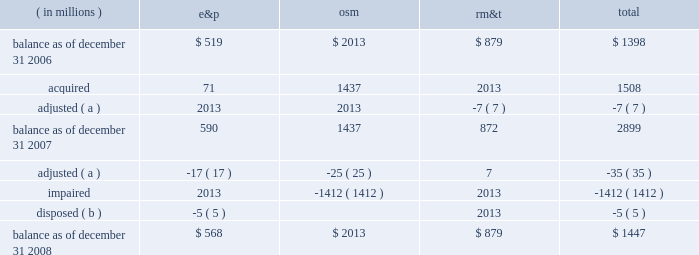Marathon oil corporation notes to consolidated financial statements the changes in the carrying amount of goodwill for the years ended december 31 , 2007 , and 2008 , were as follows : ( in millions ) e&p osm rm&t total .
( a ) adjustments related to prior period income tax and royalty adjustments .
( b ) goodwill was allocated to the norwegian outside-operated properties sold in 2008 .
17 .
Fair value measurements as defined in sfas no .
157 , fair value is the price that would be received to sell an asset or paid to transfer a liability in an orderly transaction between market participants at the measurement date .
Sfas no .
157 describes three approaches to measuring the fair value of assets and liabilities : the market approach , the income approach and the cost approach , each of which includes multiple valuation techniques .
The market approach uses prices and other relevant information generated by market transactions involving identical or comparable assets or liabilities .
The income approach uses valuation techniques to measure fair value by converting future amounts , such as cash flows or earnings , into a single present value amount using current market expectations about those future amounts .
The cost approach is based on the amount that would currently be required to replace the service capacity of an asset .
This is often referred to as current replacement cost .
The cost approach assumes that the fair value would not exceed what it would cost a market participant to acquire or construct a substitute asset of comparable utility , adjusted for obsolescence .
Sfas no .
157 does not prescribe which valuation technique should be used when measuring fair value and does not prioritize among the techniques .
Sfas no .
157 establishes a fair value hierarchy that prioritizes the inputs used in applying the various valuation techniques .
Inputs broadly refer to the assumptions that market participants use to make pricing decisions , including assumptions about risk .
Level 1 inputs are given the highest priority in the fair value hierarchy while level 3 inputs are given the lowest priority .
The three levels of the fair value hierarchy are as follows .
2022 level 1 2013 observable inputs that reflect unadjusted quoted prices for identical assets or liabilities in active markets as of the reporting date .
Active markets are those in which transactions for the asset or liability occur in sufficient frequency and volume to provide pricing information on an ongoing basis .
2022 level 2 2013 observable market-based inputs or unobservable inputs that are corroborated by market data .
These are inputs other than quoted prices in active markets included in level 1 , which are either directly or indirectly observable as of the reporting date .
2022 level 3 2013 unobservable inputs that are not corroborated by market data and may be used with internally developed methodologies that result in management 2019s best estimate of fair value .
We use a market or income approach for recurring fair value measurements and endeavor to use the best information available .
Accordingly , valuation techniques that maximize the use of observable inputs are favored .
Financial assets and liabilities are classified in their entirety based on the lowest priority level of input that is significant to the fair value measurement .
The assessment of the significance of a particular input to the fair value measurement requires judgment and may affect the placement of assets and liabilities within the levels of the fair value hierarchy. .
Excluding 2008 adjustments , what was the balance of the rm&t segment goodwill as of december 31 2008 , in millions? 
Computations: (879 - 7)
Answer: 872.0. Marathon oil corporation notes to consolidated financial statements the changes in the carrying amount of goodwill for the years ended december 31 , 2007 , and 2008 , were as follows : ( in millions ) e&p osm rm&t total .
( a ) adjustments related to prior period income tax and royalty adjustments .
( b ) goodwill was allocated to the norwegian outside-operated properties sold in 2008 .
17 .
Fair value measurements as defined in sfas no .
157 , fair value is the price that would be received to sell an asset or paid to transfer a liability in an orderly transaction between market participants at the measurement date .
Sfas no .
157 describes three approaches to measuring the fair value of assets and liabilities : the market approach , the income approach and the cost approach , each of which includes multiple valuation techniques .
The market approach uses prices and other relevant information generated by market transactions involving identical or comparable assets or liabilities .
The income approach uses valuation techniques to measure fair value by converting future amounts , such as cash flows or earnings , into a single present value amount using current market expectations about those future amounts .
The cost approach is based on the amount that would currently be required to replace the service capacity of an asset .
This is often referred to as current replacement cost .
The cost approach assumes that the fair value would not exceed what it would cost a market participant to acquire or construct a substitute asset of comparable utility , adjusted for obsolescence .
Sfas no .
157 does not prescribe which valuation technique should be used when measuring fair value and does not prioritize among the techniques .
Sfas no .
157 establishes a fair value hierarchy that prioritizes the inputs used in applying the various valuation techniques .
Inputs broadly refer to the assumptions that market participants use to make pricing decisions , including assumptions about risk .
Level 1 inputs are given the highest priority in the fair value hierarchy while level 3 inputs are given the lowest priority .
The three levels of the fair value hierarchy are as follows .
2022 level 1 2013 observable inputs that reflect unadjusted quoted prices for identical assets or liabilities in active markets as of the reporting date .
Active markets are those in which transactions for the asset or liability occur in sufficient frequency and volume to provide pricing information on an ongoing basis .
2022 level 2 2013 observable market-based inputs or unobservable inputs that are corroborated by market data .
These are inputs other than quoted prices in active markets included in level 1 , which are either directly or indirectly observable as of the reporting date .
2022 level 3 2013 unobservable inputs that are not corroborated by market data and may be used with internally developed methodologies that result in management 2019s best estimate of fair value .
We use a market or income approach for recurring fair value measurements and endeavor to use the best information available .
Accordingly , valuation techniques that maximize the use of observable inputs are favored .
Financial assets and liabilities are classified in their entirety based on the lowest priority level of input that is significant to the fair value measurement .
The assessment of the significance of a particular input to the fair value measurement requires judgment and may affect the placement of assets and liabilities within the levels of the fair value hierarchy. .
What percentage of end of the year 2008 total goodwill does rm&t consist of? 
Computations: (879 / 1447)
Answer: 0.60746. 